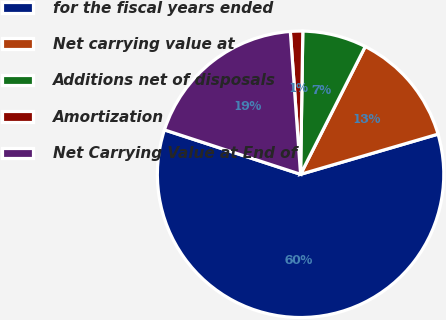Convert chart. <chart><loc_0><loc_0><loc_500><loc_500><pie_chart><fcel>for the fiscal years ended<fcel>Net carrying value at<fcel>Additions net of disposals<fcel>Amortization<fcel>Net Carrying Value at End of<nl><fcel>59.55%<fcel>13.02%<fcel>7.21%<fcel>1.39%<fcel>18.84%<nl></chart> 